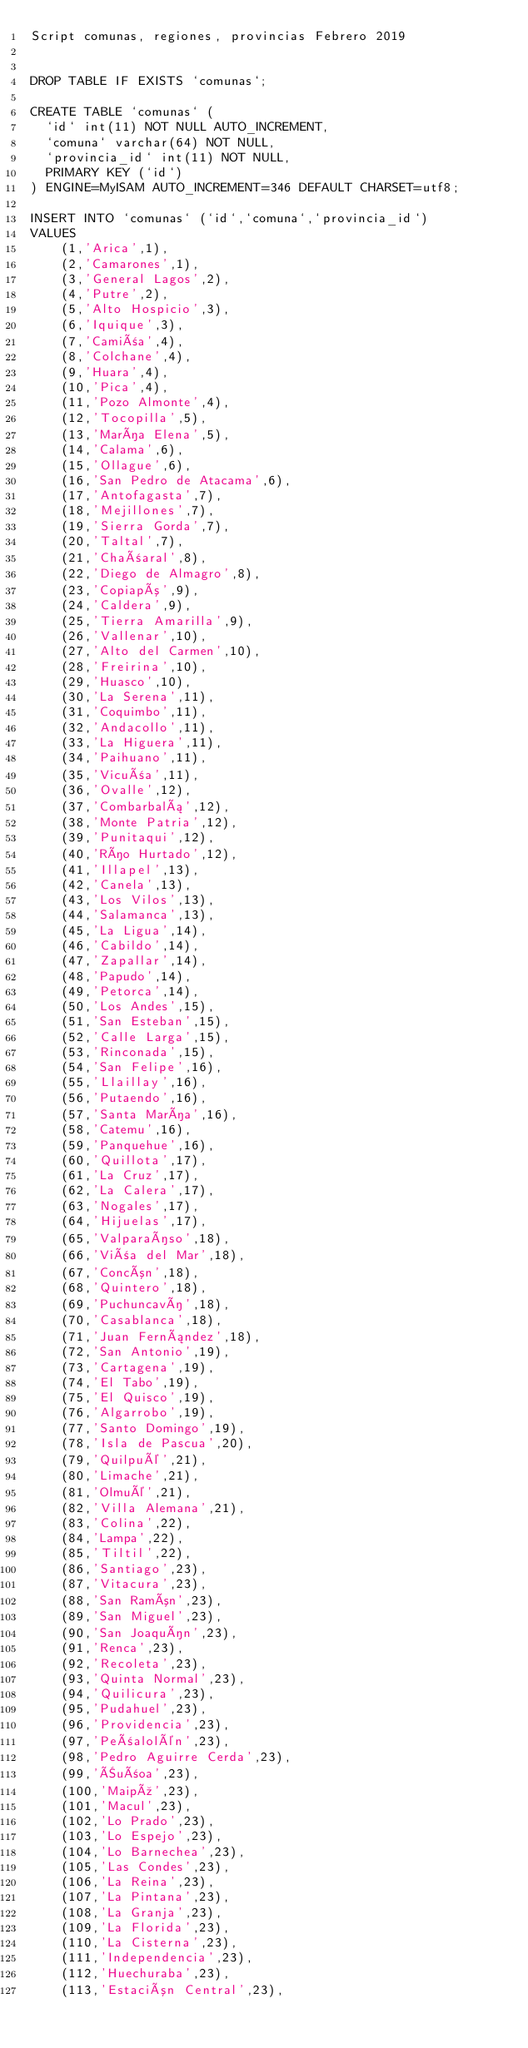Convert code to text. <code><loc_0><loc_0><loc_500><loc_500><_SQL_>Script comunas, regiones, provincias Febrero 2019


DROP TABLE IF EXISTS `comunas`;

CREATE TABLE `comunas` (
  `id` int(11) NOT NULL AUTO_INCREMENT,
  `comuna` varchar(64) NOT NULL,
  `provincia_id` int(11) NOT NULL,
  PRIMARY KEY (`id`)
) ENGINE=MyISAM AUTO_INCREMENT=346 DEFAULT CHARSET=utf8;

INSERT INTO `comunas` (`id`,`comuna`,`provincia_id`)
VALUES
	(1,'Arica',1),
	(2,'Camarones',1),
	(3,'General Lagos',2),
	(4,'Putre',2),
	(5,'Alto Hospicio',3),
	(6,'Iquique',3),
	(7,'Camiña',4),
	(8,'Colchane',4),
	(9,'Huara',4),
	(10,'Pica',4),
	(11,'Pozo Almonte',4),
  	(12,'Tocopilla',5),
  	(13,'María Elena',5),
	(14,'Calama',6),
	(15,'Ollague',6),
	(16,'San Pedro de Atacama',6),
  	(17,'Antofagasta',7),
	(18,'Mejillones',7),
	(19,'Sierra Gorda',7),
	(20,'Taltal',7),
	(21,'Chañaral',8),
	(22,'Diego de Almagro',8),
  	(23,'Copiapó',9),
	(24,'Caldera',9),
	(25,'Tierra Amarilla',9),
  	(26,'Vallenar',10),
	(27,'Alto del Carmen',10),
	(28,'Freirina',10),
	(29,'Huasco',10),
	(30,'La Serena',11),
  	(31,'Coquimbo',11),
  	(32,'Andacollo',11),
  	(33,'La Higuera',11),
  	(34,'Paihuano',11),
	(35,'Vicuña',11),
	(36,'Ovalle',12),
  	(37,'Combarbalá',12),
  	(38,'Monte Patria',12),
  	(39,'Punitaqui',12),
	(40,'Río Hurtado',12),
	(41,'Illapel',13),
	(42,'Canela',13),
	(43,'Los Vilos',13),
	(44,'Salamanca',13),
	(45,'La Ligua',14),
  	(46,'Cabildo',14),
	(47,'Zapallar',14),
  	(48,'Papudo',14),
	(49,'Petorca',14),
	(50,'Los Andes',15),
	(51,'San Esteban',15),
  	(52,'Calle Larga',15),
  	(53,'Rinconada',15),
	(54,'San Felipe',16),
  	(55,'Llaillay',16),
  	(56,'Putaendo',16),
	(57,'Santa María',16),
	(58,'Catemu',16),
	(59,'Panquehue',16),
  	(60,'Quillota',17),
  	(61,'La Cruz',17),
	(62,'La Calera',17),
	(63,'Nogales',17),
  	(64,'Hijuelas',17),
	(65,'Valparaíso',18),	
  	(66,'Viña del Mar',18),
	(67,'Concón',18),
 	(68,'Quintero',18),
  	(69,'Puchuncaví',18),
	(70,'Casablanca',18),
	(71,'Juan Fernández',18),
	(72,'San Antonio',19),
  	(73,'Cartagena',19),
	(74,'El Tabo',19),
	(75,'El Quisco',19),
	(76,'Algarrobo',19),
	(77,'Santo Domingo',19),
	(78,'Isla de Pascua',20),
	(79,'Quilpué',21),
	(80,'Limache',21),
	(81,'Olmué',21),
	(82,'Villa Alemana',21),
	(83,'Colina',22),
	(84,'Lampa',22),
	(85,'Tiltil',22),
	(86,'Santiago',23),
	(87,'Vitacura',23),
  	(88,'San Ramón',23),
	(89,'San Miguel',23),
	(90,'San Joaquín',23),
  	(91,'Renca',23),
	(92,'Recoleta',23),
  	(93,'Quinta Normal',23),
	(94,'Quilicura',23),
  	(95,'Pudahuel',23),
  	(96,'Providencia',23),
	(97,'Peñalolén',23),
  	(98,'Pedro Aguirre Cerda',23),
	(99,'Ñuñoa',23),
	(100,'Maipú',23),
	(101,'Macul',23),
	(102,'Lo Prado',23),
	(103,'Lo Espejo',23),
	(104,'Lo Barnechea',23),
	(105,'Las Condes',23),
	(106,'La Reina',23),
	(107,'La Pintana',23),
	(108,'La Granja',23),
	(109,'La Florida',23),
  	(110,'La Cisterna',23),
  	(111,'Independencia',23),
  	(112,'Huechuraba',23),
	(113,'Estación Central',23),</code> 